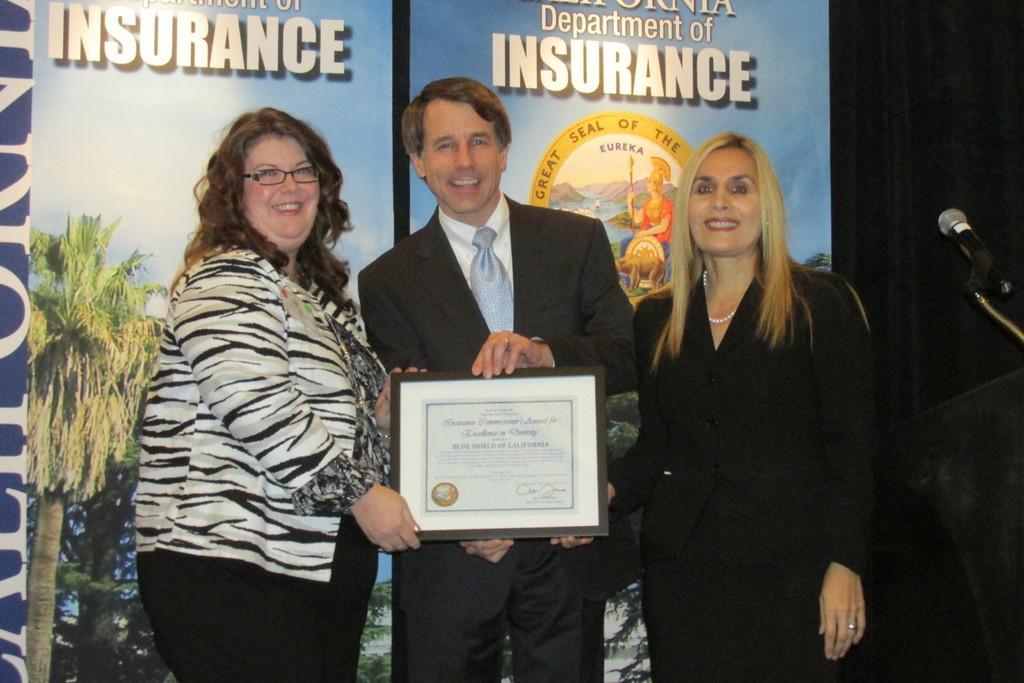Can you describe this image briefly? There are three people standing and smiling and this man holding a frame and we can see microphone with stand. In the background we can see banners and it is dark. 